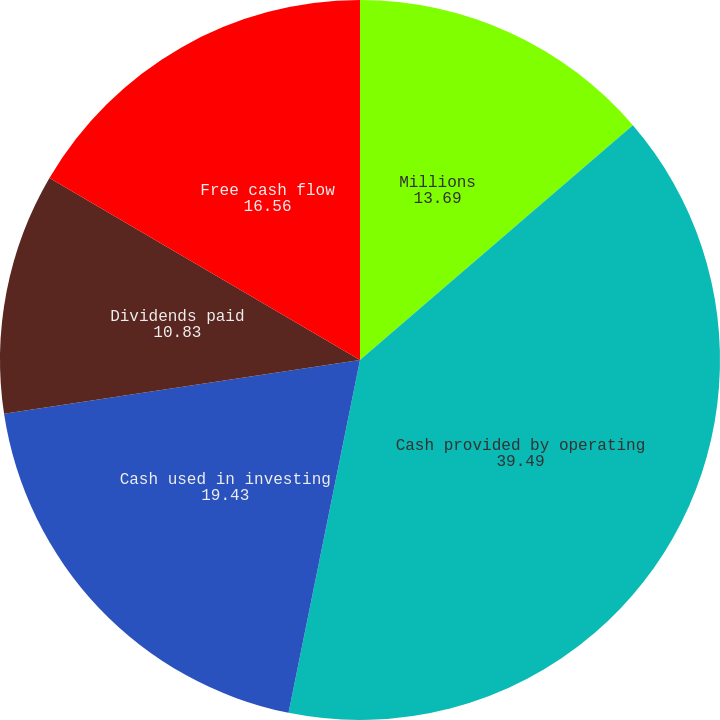Convert chart to OTSL. <chart><loc_0><loc_0><loc_500><loc_500><pie_chart><fcel>Millions<fcel>Cash provided by operating<fcel>Cash used in investing<fcel>Dividends paid<fcel>Free cash flow<nl><fcel>13.69%<fcel>39.49%<fcel>19.43%<fcel>10.83%<fcel>16.56%<nl></chart> 